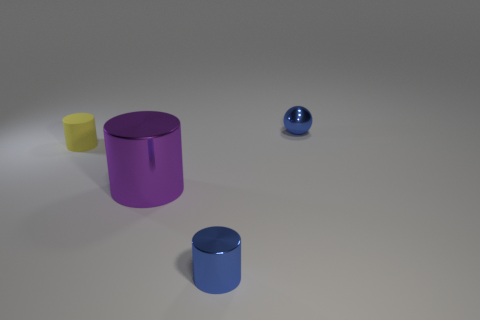What shape is the blue object that is the same material as the tiny blue ball?
Ensure brevity in your answer.  Cylinder. How many small objects are behind the yellow rubber cylinder and in front of the big purple cylinder?
Give a very brief answer. 0. There is a small yellow matte cylinder; are there any purple metal things to the right of it?
Offer a terse response. Yes. Is the shape of the blue object that is in front of the purple shiny cylinder the same as the tiny rubber object left of the purple cylinder?
Give a very brief answer. Yes. How many things are either purple cylinders or metal things in front of the blue sphere?
Provide a succinct answer. 2. How many other things are the same shape as the small yellow matte object?
Ensure brevity in your answer.  2. Is the thing that is in front of the purple object made of the same material as the large cylinder?
Provide a succinct answer. Yes. How many objects are either large blocks or blue metallic spheres?
Give a very brief answer. 1. What is the size of the blue shiny thing that is the same shape as the small matte object?
Provide a short and direct response. Small. The matte cylinder is what size?
Offer a terse response. Small. 